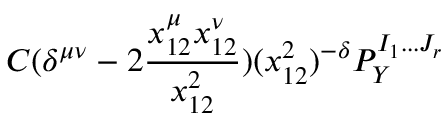Convert formula to latex. <formula><loc_0><loc_0><loc_500><loc_500>C ( \delta ^ { \mu \nu } - 2 \frac { x _ { 1 2 } ^ { \mu } x _ { 1 2 } ^ { \nu } } { x _ { 1 2 } ^ { 2 } } ) ( x _ { 1 2 } ^ { 2 } ) ^ { - \delta } P _ { Y } ^ { I _ { 1 } \dots J _ { r } }</formula> 